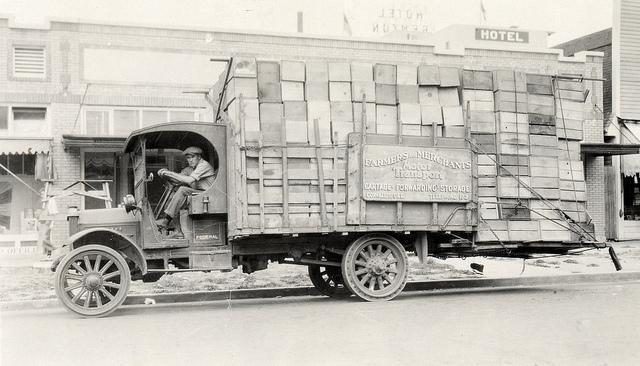How many people are in this picture?
Give a very brief answer. 1. How many blue buses are there?
Give a very brief answer. 0. 